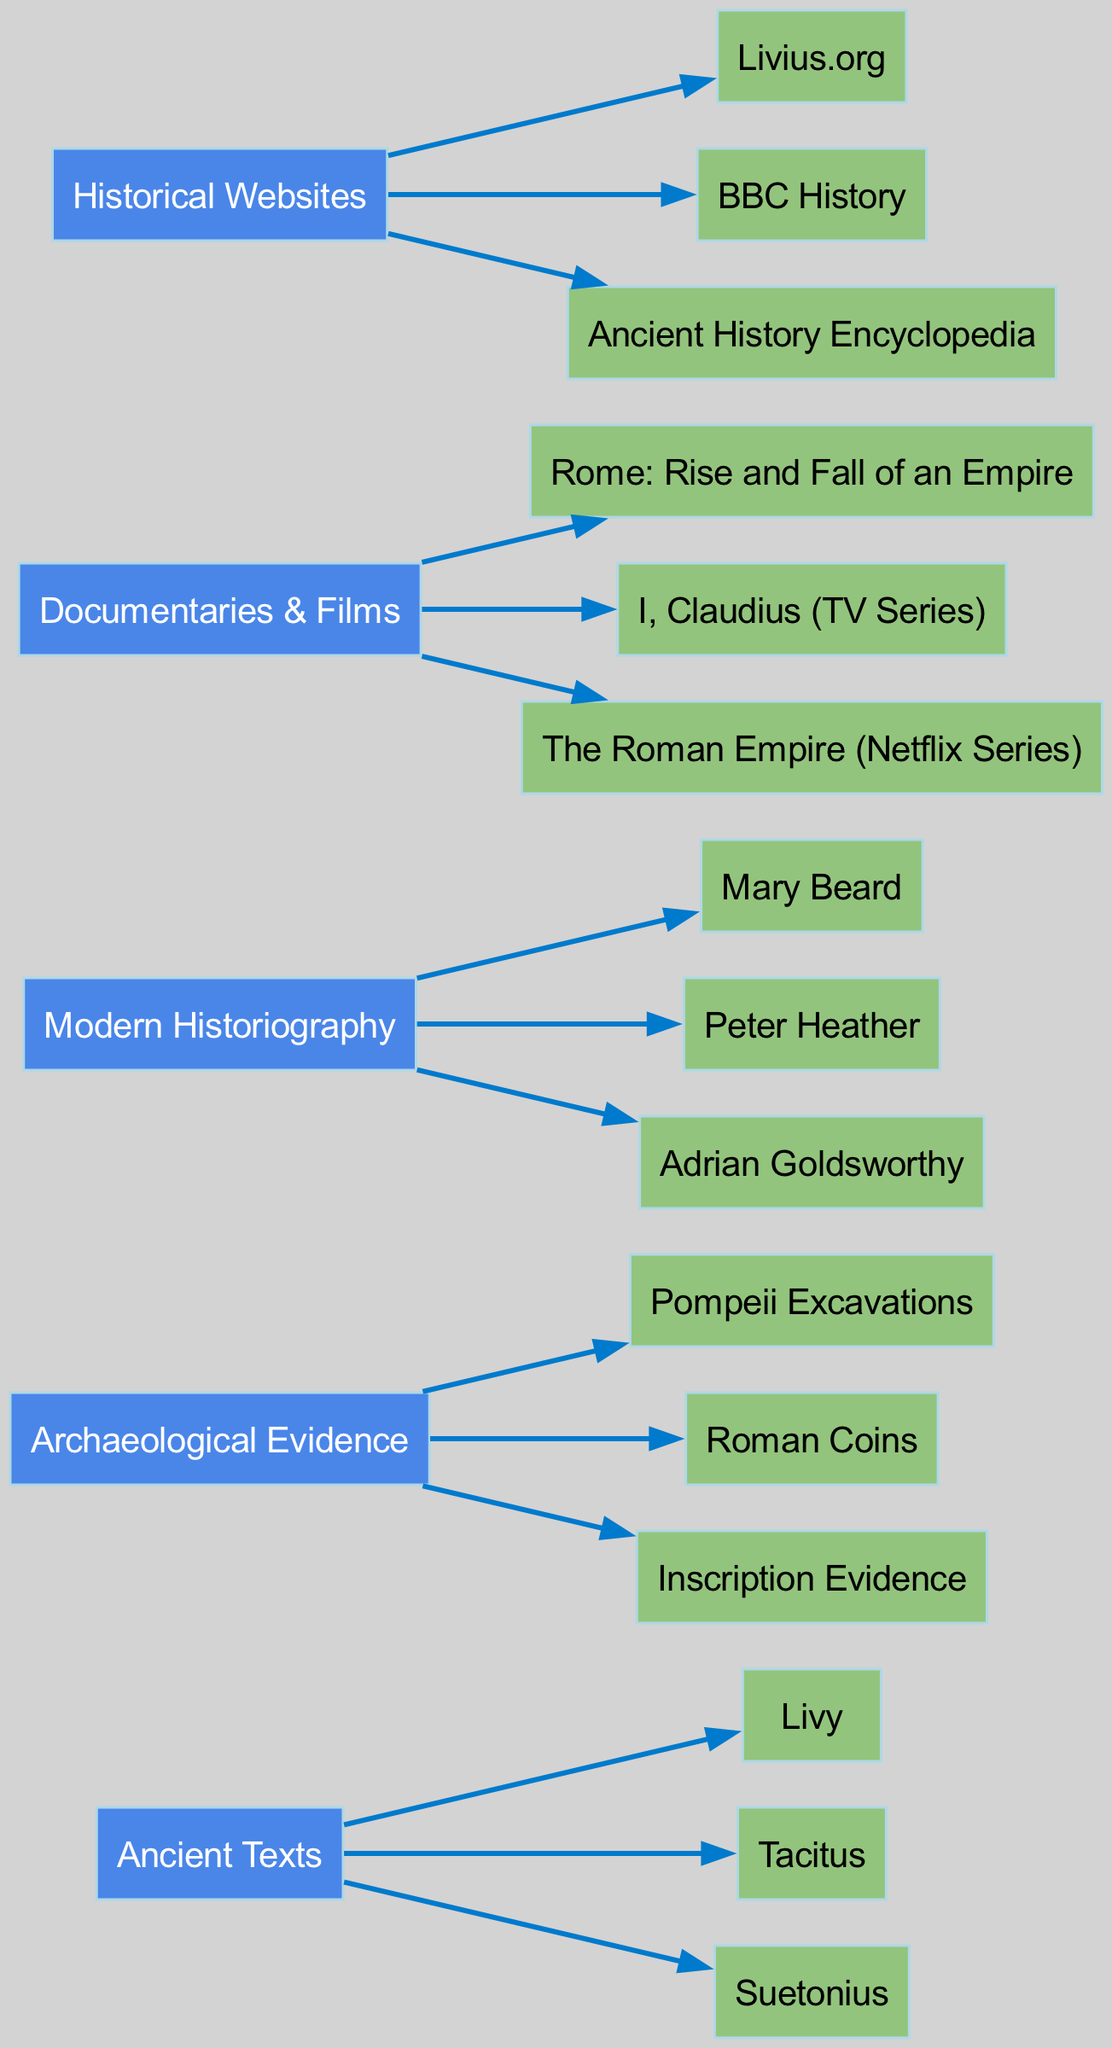What is the total number of main sources in the diagram? The diagram lists five main sources: Ancient Texts, Archaeological Evidence, Modern Historiography, Documentaries & Films, and Historical Websites. By counting these, the total is five.
Answer: 5 Which sub-source is connected to the source "Documentaries & Films"? Looking at the sub-sources associated with Documentaries & Films, they are "Rome: Rise and Fall of an Empire," "I, Claudius (TV Series)," and "The Roman Empire (Netflix Series)." Thus, all three are connected to this source.
Answer: Rome: Rise and Fall of an Empire, I, Claudius (TV Series), The Roman Empire (Netflix Series) How many sub-sources belong to "Ancient Texts"? The Ancient Texts source lists three sub-sources: Livy, Tacitus, and Suetonius. Counting these, we find there are three sub-sources.
Answer: 3 Which main source has the highest number of sub-sources? Comparing the number of sub-sources from each main source, "Ancient Texts" (3), "Archaeological Evidence" (3), "Modern Historiography" (3), "Documentaries & Films" (3), and "Historical Websites" (3) all have three. Thus, no single source has more; they are tied.
Answer: None What is the relationship between "Mary Beard" and "Modern Historiography"? Mary Beard is one of the sub-sources listed under the main source "Modern Historiography." This indicates a direct connection as she contributes to that category.
Answer: Connected How many different types of sources are shown in the diagram? The diagram differentiates between five types of main sources: Ancient Texts, Archaeological Evidence, Modern Historiography, Documentaries & Films, and Historical Websites. Counting these types gives five different categories.
Answer: 5 Which source has the sub-source "Pompeii Excavations"? The sub-source "Pompeii Excavations" is associated with the main source "Archaeological Evidence," indicating a direct link between them.
Answer: Archaeological Evidence Name one sub-source related to "Historical Websites." The sub-sources under "Historical Websites" include Livius.org, BBC History, and Ancient History Encyclopedia. Hence, any of these can serve as an answer. For example, Livius.org.
Answer: Livius.org Which main source is associated with the scholar "Adrian Goldsworthy"? Adrian Goldsworthy is part of the sub-sources under "Modern Historiography." This indicates that the main source provides insights related to this scholar.
Answer: Modern Historiography 